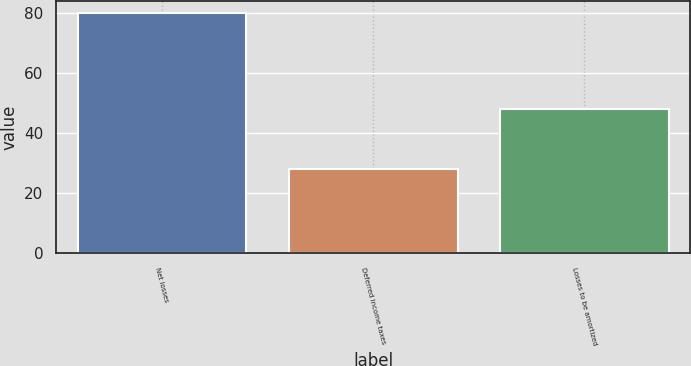Convert chart to OTSL. <chart><loc_0><loc_0><loc_500><loc_500><bar_chart><fcel>Net losses<fcel>Deferred income taxes<fcel>Losses to be amortized<nl><fcel>80<fcel>28<fcel>48<nl></chart> 